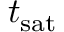Convert formula to latex. <formula><loc_0><loc_0><loc_500><loc_500>t _ { s a t }</formula> 